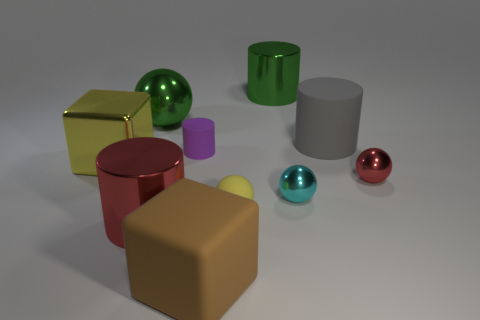Subtract all matte balls. How many balls are left? 3 Subtract all brown cubes. How many cubes are left? 1 Subtract 1 blocks. How many blocks are left? 1 Subtract all cylinders. How many objects are left? 6 Subtract 0 cyan blocks. How many objects are left? 10 Subtract all brown cylinders. Subtract all red blocks. How many cylinders are left? 4 Subtract all cyan cubes. How many yellow cylinders are left? 0 Subtract all small blue objects. Subtract all gray rubber things. How many objects are left? 9 Add 1 tiny matte objects. How many tiny matte objects are left? 3 Add 8 large cyan rubber blocks. How many large cyan rubber blocks exist? 8 